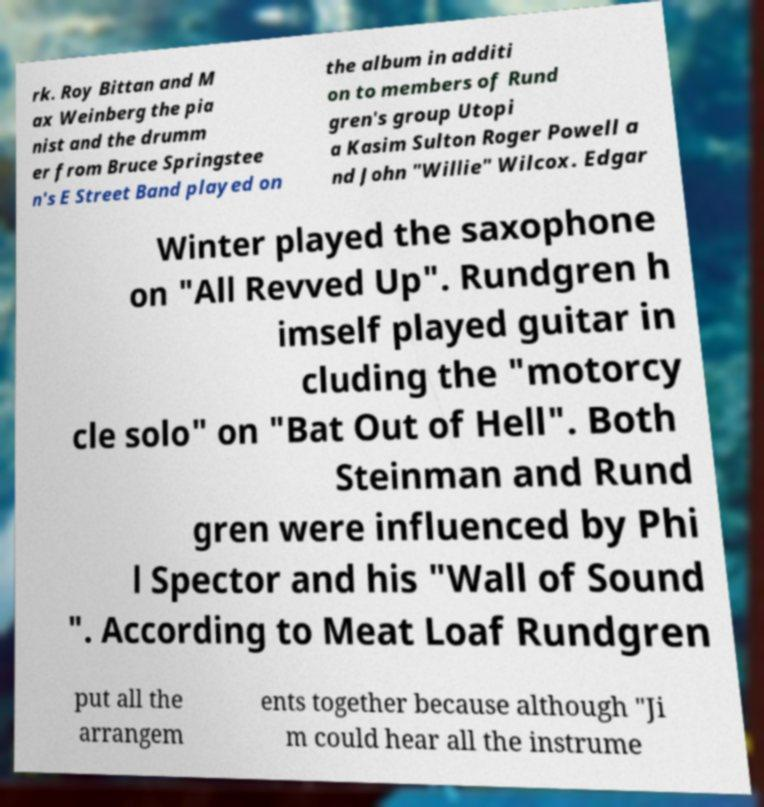Please read and relay the text visible in this image. What does it say? rk. Roy Bittan and M ax Weinberg the pia nist and the drumm er from Bruce Springstee n's E Street Band played on the album in additi on to members of Rund gren's group Utopi a Kasim Sulton Roger Powell a nd John "Willie" Wilcox. Edgar Winter played the saxophone on "All Revved Up". Rundgren h imself played guitar in cluding the "motorcy cle solo" on "Bat Out of Hell". Both Steinman and Rund gren were influenced by Phi l Spector and his "Wall of Sound ". According to Meat Loaf Rundgren put all the arrangem ents together because although "Ji m could hear all the instrume 